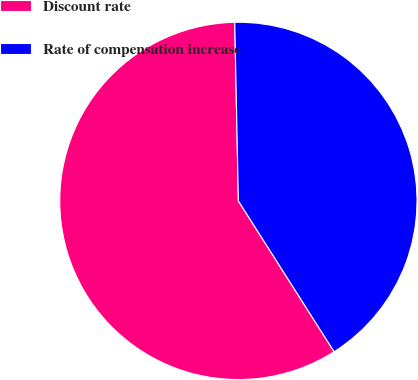Convert chart. <chart><loc_0><loc_0><loc_500><loc_500><pie_chart><fcel>Discount rate<fcel>Rate of compensation increase<nl><fcel>58.68%<fcel>41.32%<nl></chart> 